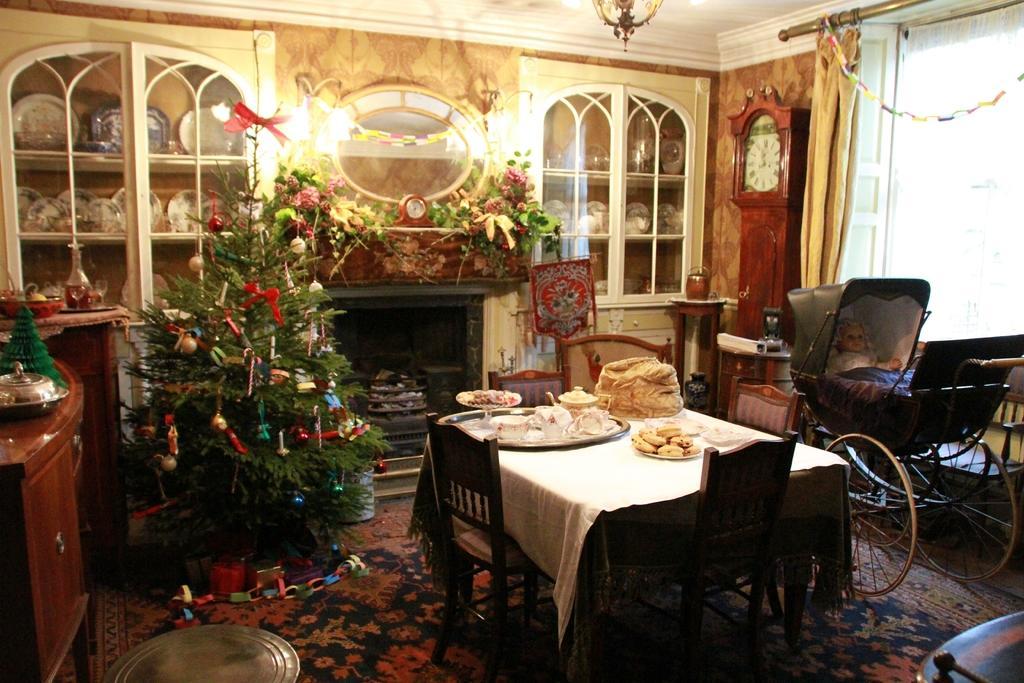Please provide a concise description of this image. This picture shows a christmas tree and a food on the table and we see few chairs around the table. 